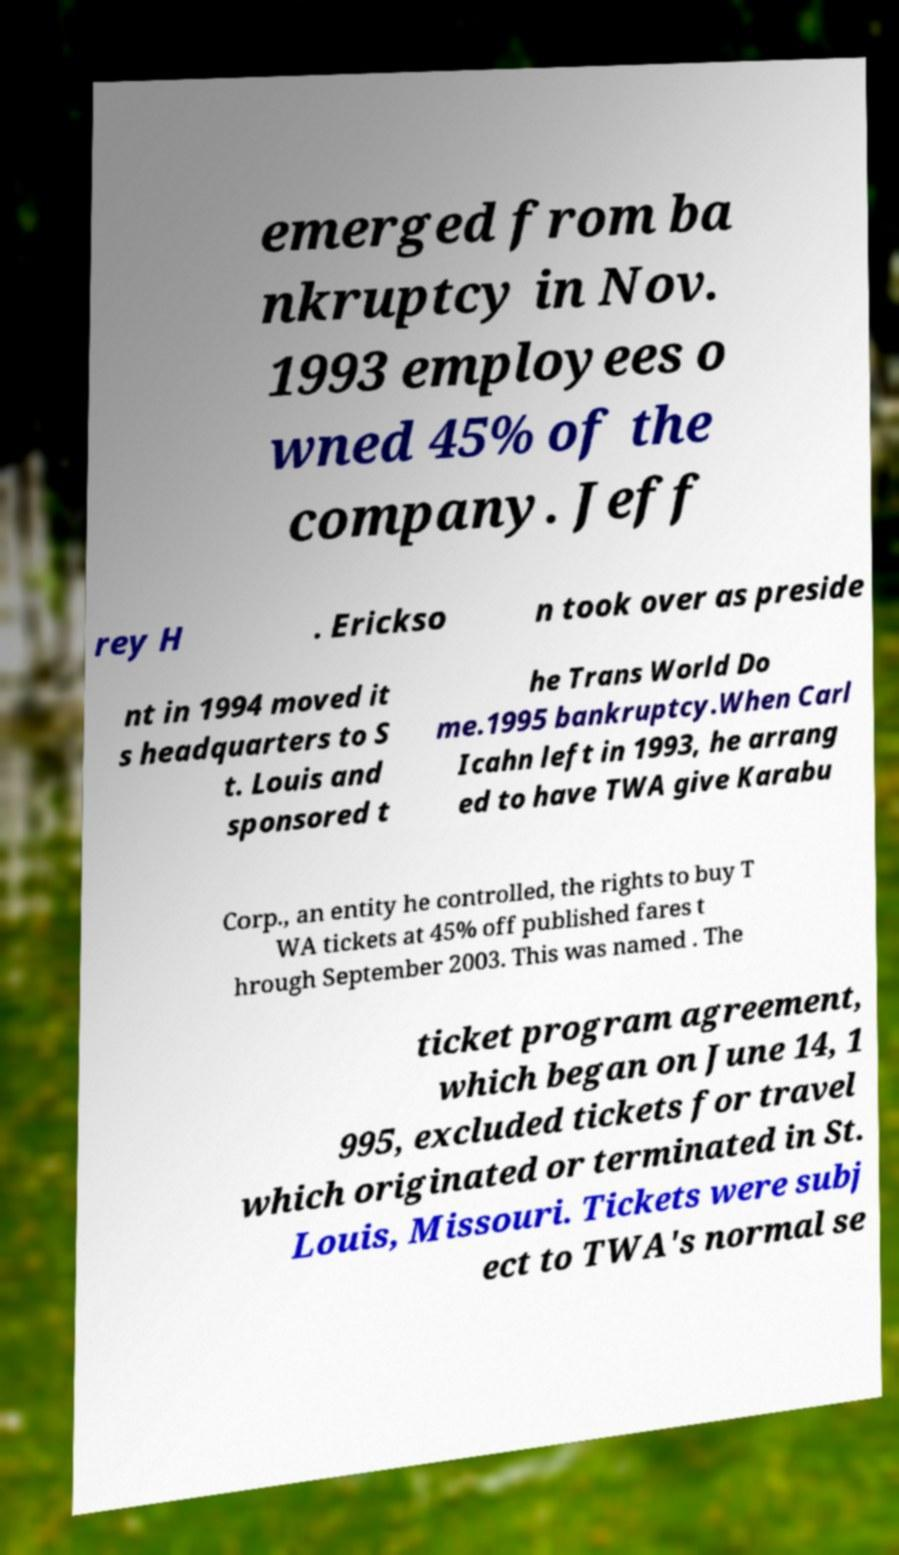Could you extract and type out the text from this image? emerged from ba nkruptcy in Nov. 1993 employees o wned 45% of the company. Jeff rey H . Erickso n took over as preside nt in 1994 moved it s headquarters to S t. Louis and sponsored t he Trans World Do me.1995 bankruptcy.When Carl Icahn left in 1993, he arrang ed to have TWA give Karabu Corp., an entity he controlled, the rights to buy T WA tickets at 45% off published fares t hrough September 2003. This was named . The ticket program agreement, which began on June 14, 1 995, excluded tickets for travel which originated or terminated in St. Louis, Missouri. Tickets were subj ect to TWA's normal se 